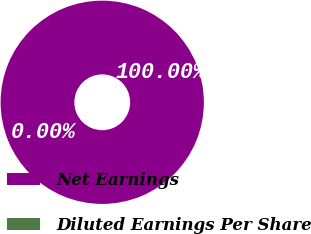<chart> <loc_0><loc_0><loc_500><loc_500><pie_chart><fcel>Net Earnings<fcel>Diluted Earnings Per Share<nl><fcel>100.0%<fcel>0.0%<nl></chart> 